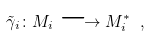Convert formula to latex. <formula><loc_0><loc_0><loc_500><loc_500>\tilde { \gamma } _ { i } \colon M _ { i } \longrightarrow M _ { i } ^ { * } \ ,</formula> 